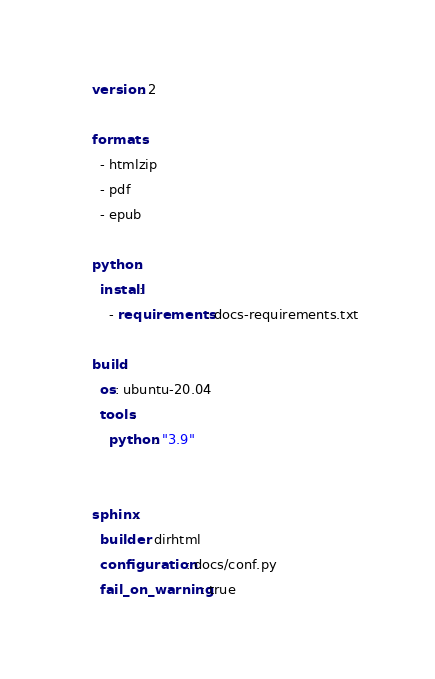<code> <loc_0><loc_0><loc_500><loc_500><_YAML_>version: 2

formats:
  - htmlzip
  - pdf
  - epub

python:
  install:
    - requirements: docs-requirements.txt

build:
  os: ubuntu-20.04
  tools:
    python: "3.9"


sphinx:
  builder: dirhtml
  configuration: docs/conf.py
  fail_on_warning: true
</code> 